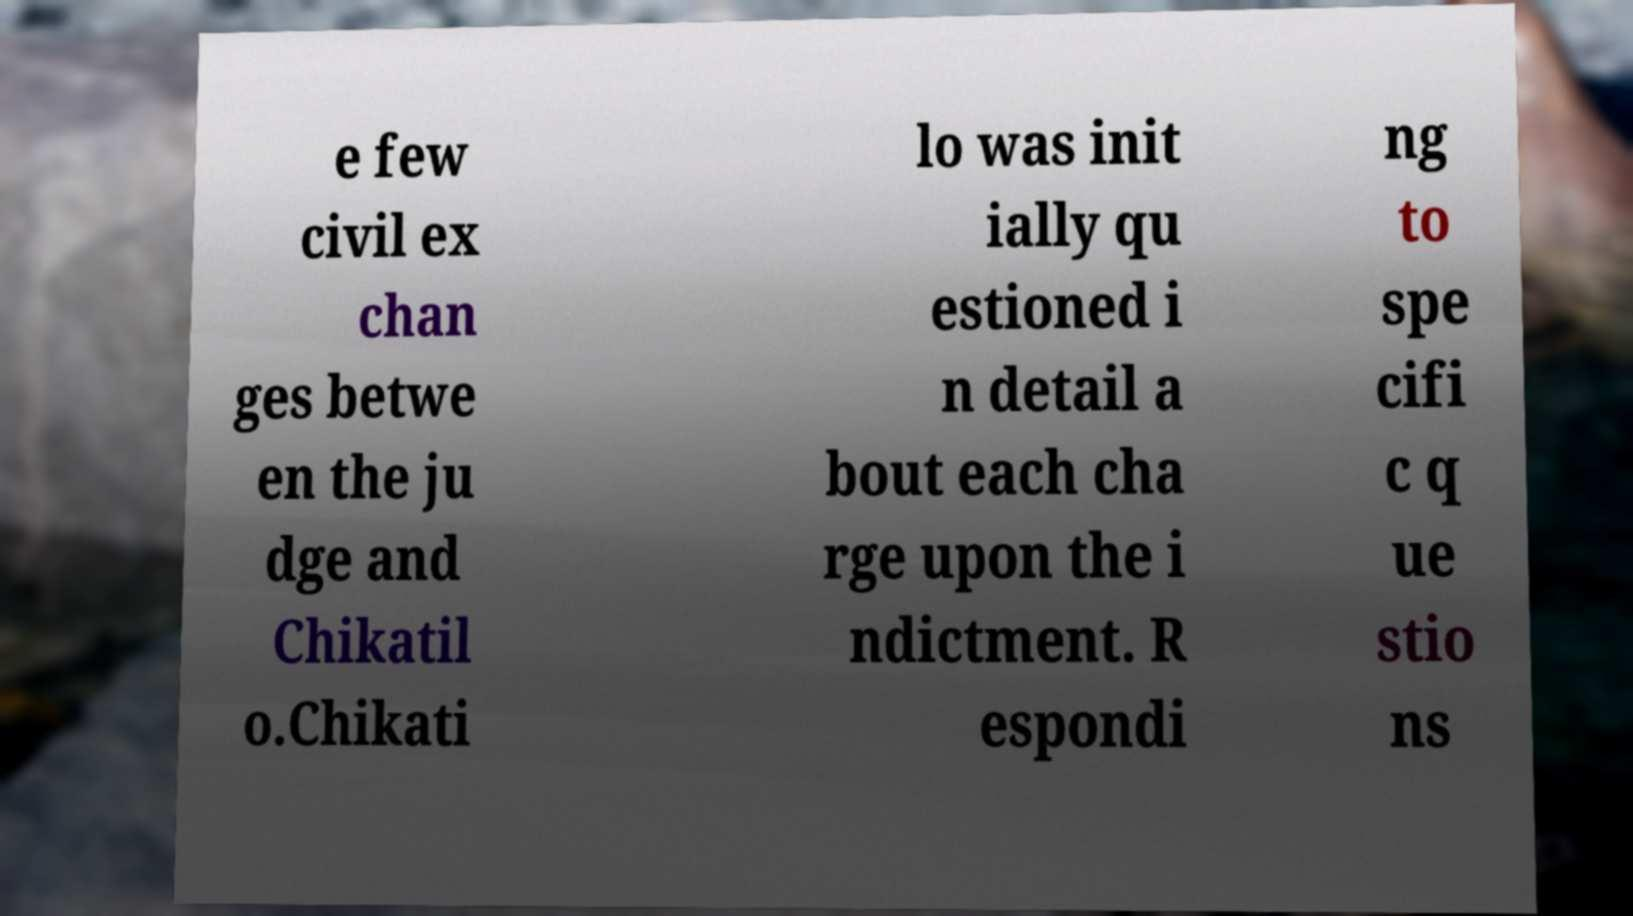There's text embedded in this image that I need extracted. Can you transcribe it verbatim? e few civil ex chan ges betwe en the ju dge and Chikatil o.Chikati lo was init ially qu estioned i n detail a bout each cha rge upon the i ndictment. R espondi ng to spe cifi c q ue stio ns 